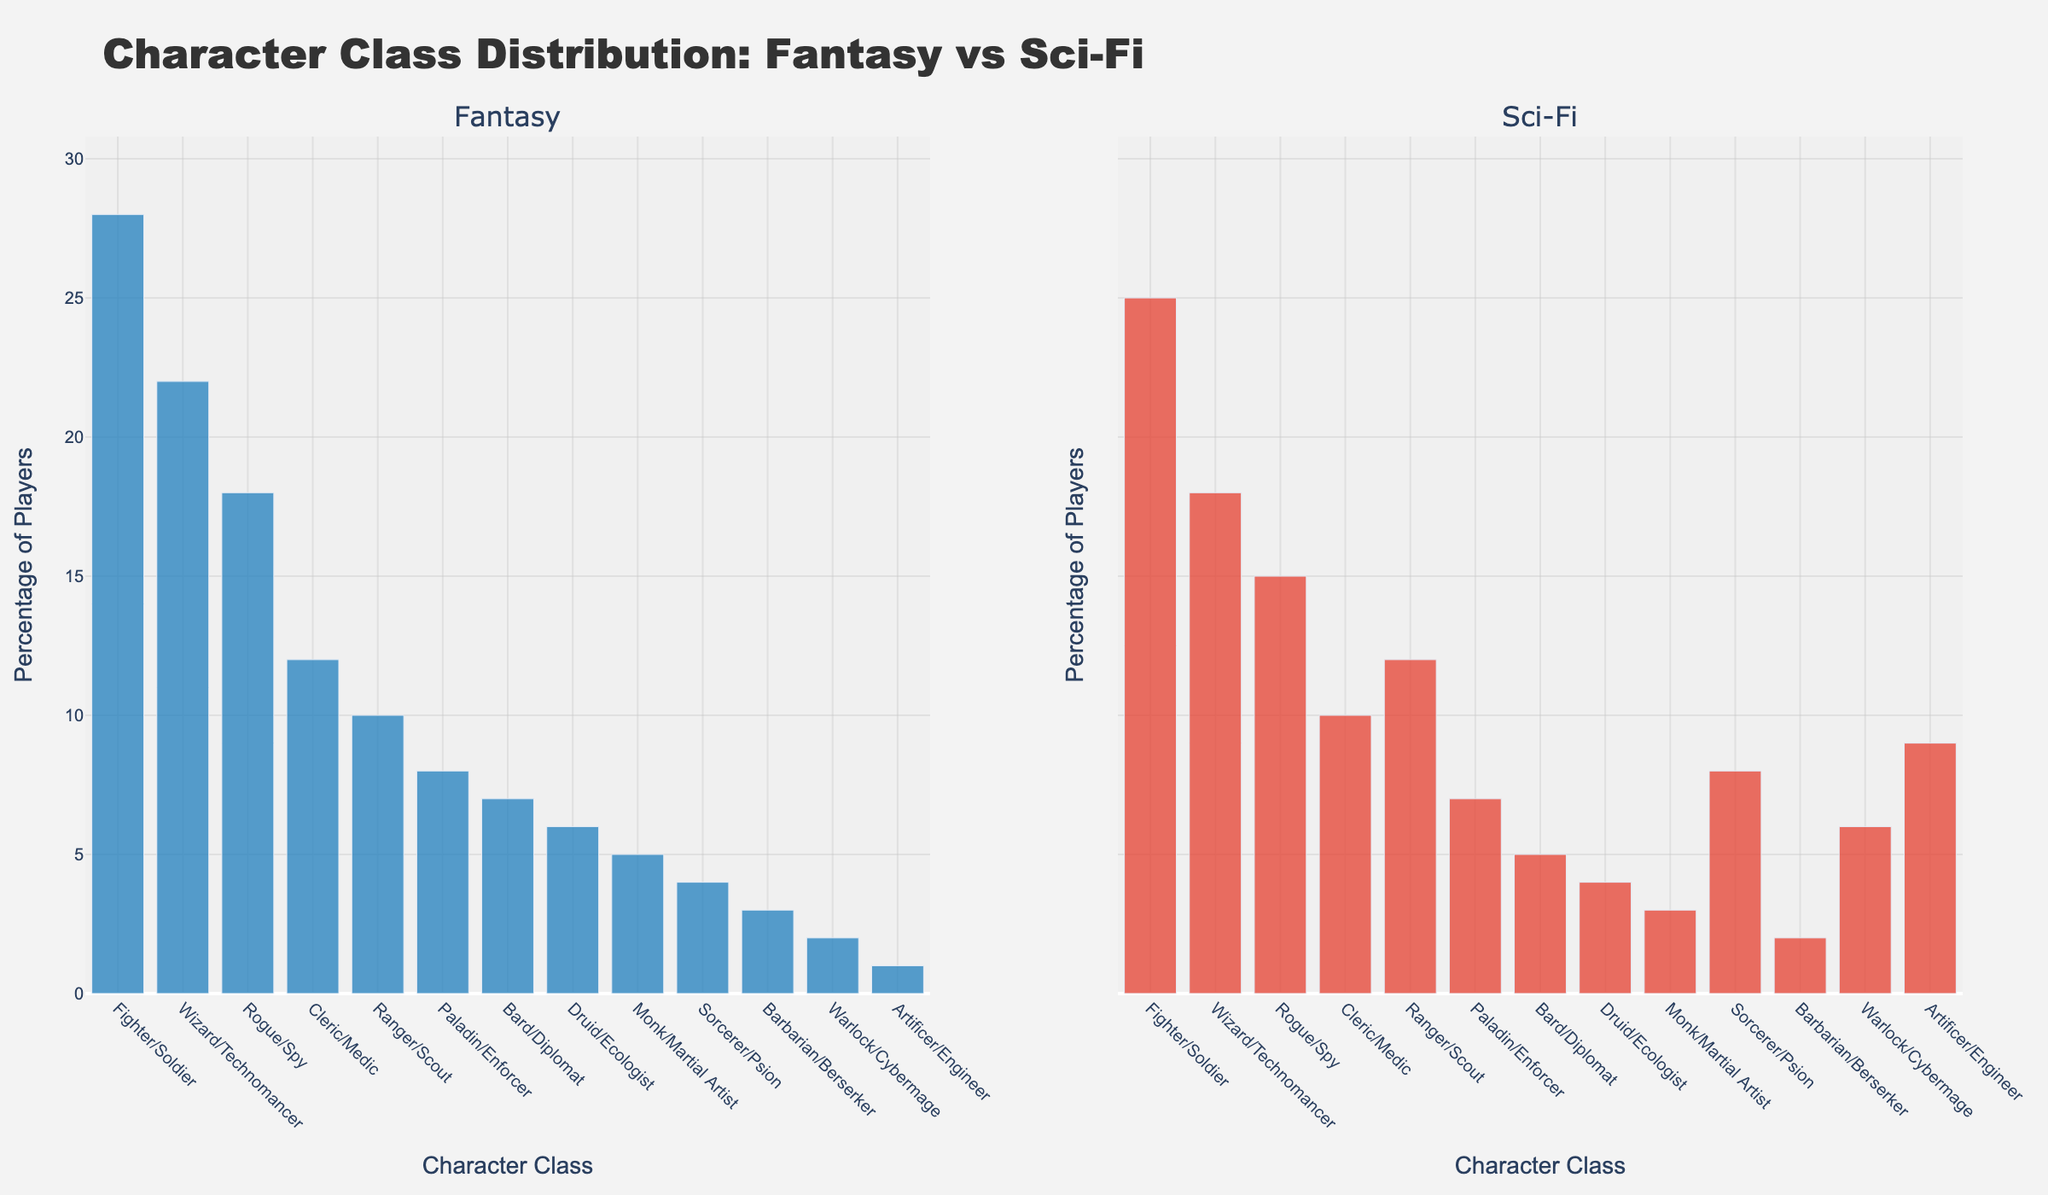What's the most popular character class chosen by new players in the fantasy setting? The tallest bar in the Fantasy subplot represents the most popular class. The Fighter/Soldier class has the tallest bar with a height of 28.
Answer: Fighter/Soldier How does the percentage of Wizard/Technomancer players compare between fantasy and sci-fi settings? In the Fantasy subplot, the height of the Wizard bar is 22, and in the Sci-Fi subplot, the height of the Technomancer bar is 18. Hence, the Wizard is chosen 4% more often than the Technomancer.
Answer: 4% more in Fantasy Which character class has the smallest difference in popularity between fantasy and sci-fi settings? We find the absolute differences between the heights in both subplots: Warlock/Cybermage has an absolute difference of 4 (6 - 2), the smallest among all classes.
Answer: Warlock/Cybermage What is the average percentage of players choosing Ranger/Scout and Sorcerer/Psion in the sci-fi setting? Sum the percentages for Ranger/Scout (12) and Sorcerer/Psion (8) and divide by 2 to get their average: (12 + 8) / 2 = 10.
Answer: 10% Are there any classes that are more popular in sci-fi than in fantasy? We compare the heights of bars for each class in both subplots. Sorcerer/Psion (8 vs. 4), Warlock/Cybermage (6 vs. 2), and Artificer/Engineer (9 vs. 1) are more popular in sci-fi.
Answer: Yes, 3 classes What's the total percentage of players choosing Cleric/Medic and Bard/Diplomat classes in the fantasy setting? Add the heights of Cleric and Bard bars in the Fantasy subplot: 12 + 7 = 19.
Answer: 19% Which character class pairs have equal popularity in both settings? We look for bars with equal heights in both subplots: None of the classes have equal popularity in both settings.
Answer: None How much higher is the percentage of Rogue/Spy compared to Monk/Martial Artist in the Fantasy setting? Subtract the height of the Monk bar from the Rogue bar in the Fantasy subplot: 18 - 5 = 13.
Answer: 13% higher What is the cumulative percentage of players choosing either Paladin/Enforcer or Barbarian/Berserker in both settings? Add the heights of respective bars in both subplots: Fantasy: 8 + 3 = 11, Sci-Fi: 7 + 2 = 9, Total: 11 + 9 = 20.
Answer: 20% 